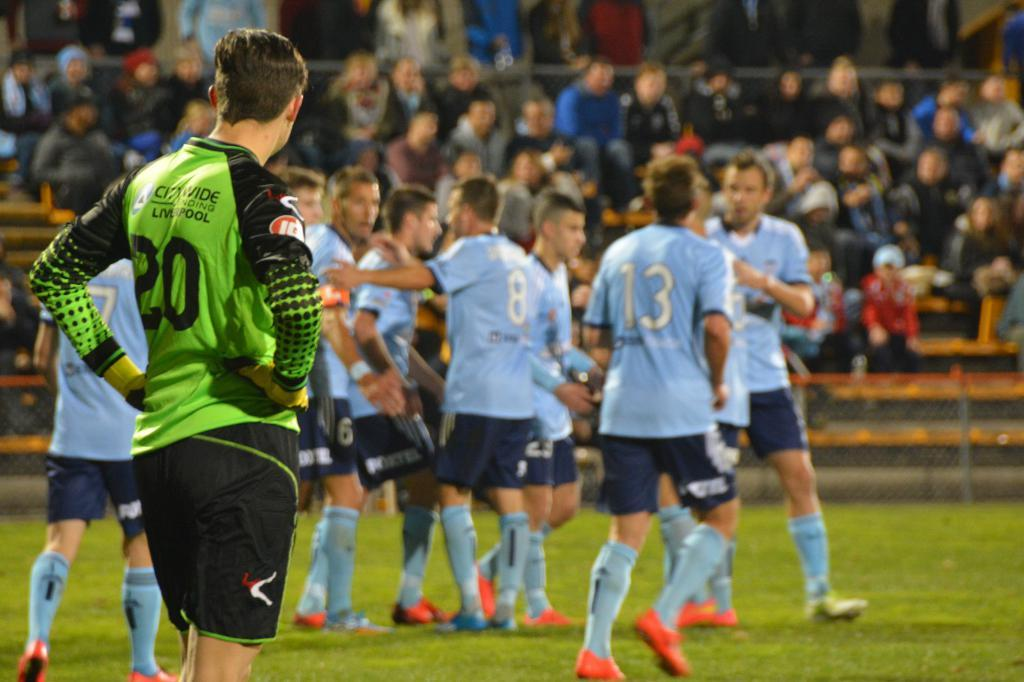<image>
Share a concise interpretation of the image provided. many players and one with the number 3 